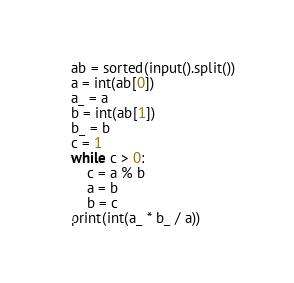Convert code to text. <code><loc_0><loc_0><loc_500><loc_500><_Python_>ab = sorted(input().split())
a = int(ab[0])
a_ = a
b = int(ab[1])
b_ = b
c = 1
while c > 0:
    c = a % b
    a = b
    b = c
print(int(a_ * b_ / a))</code> 